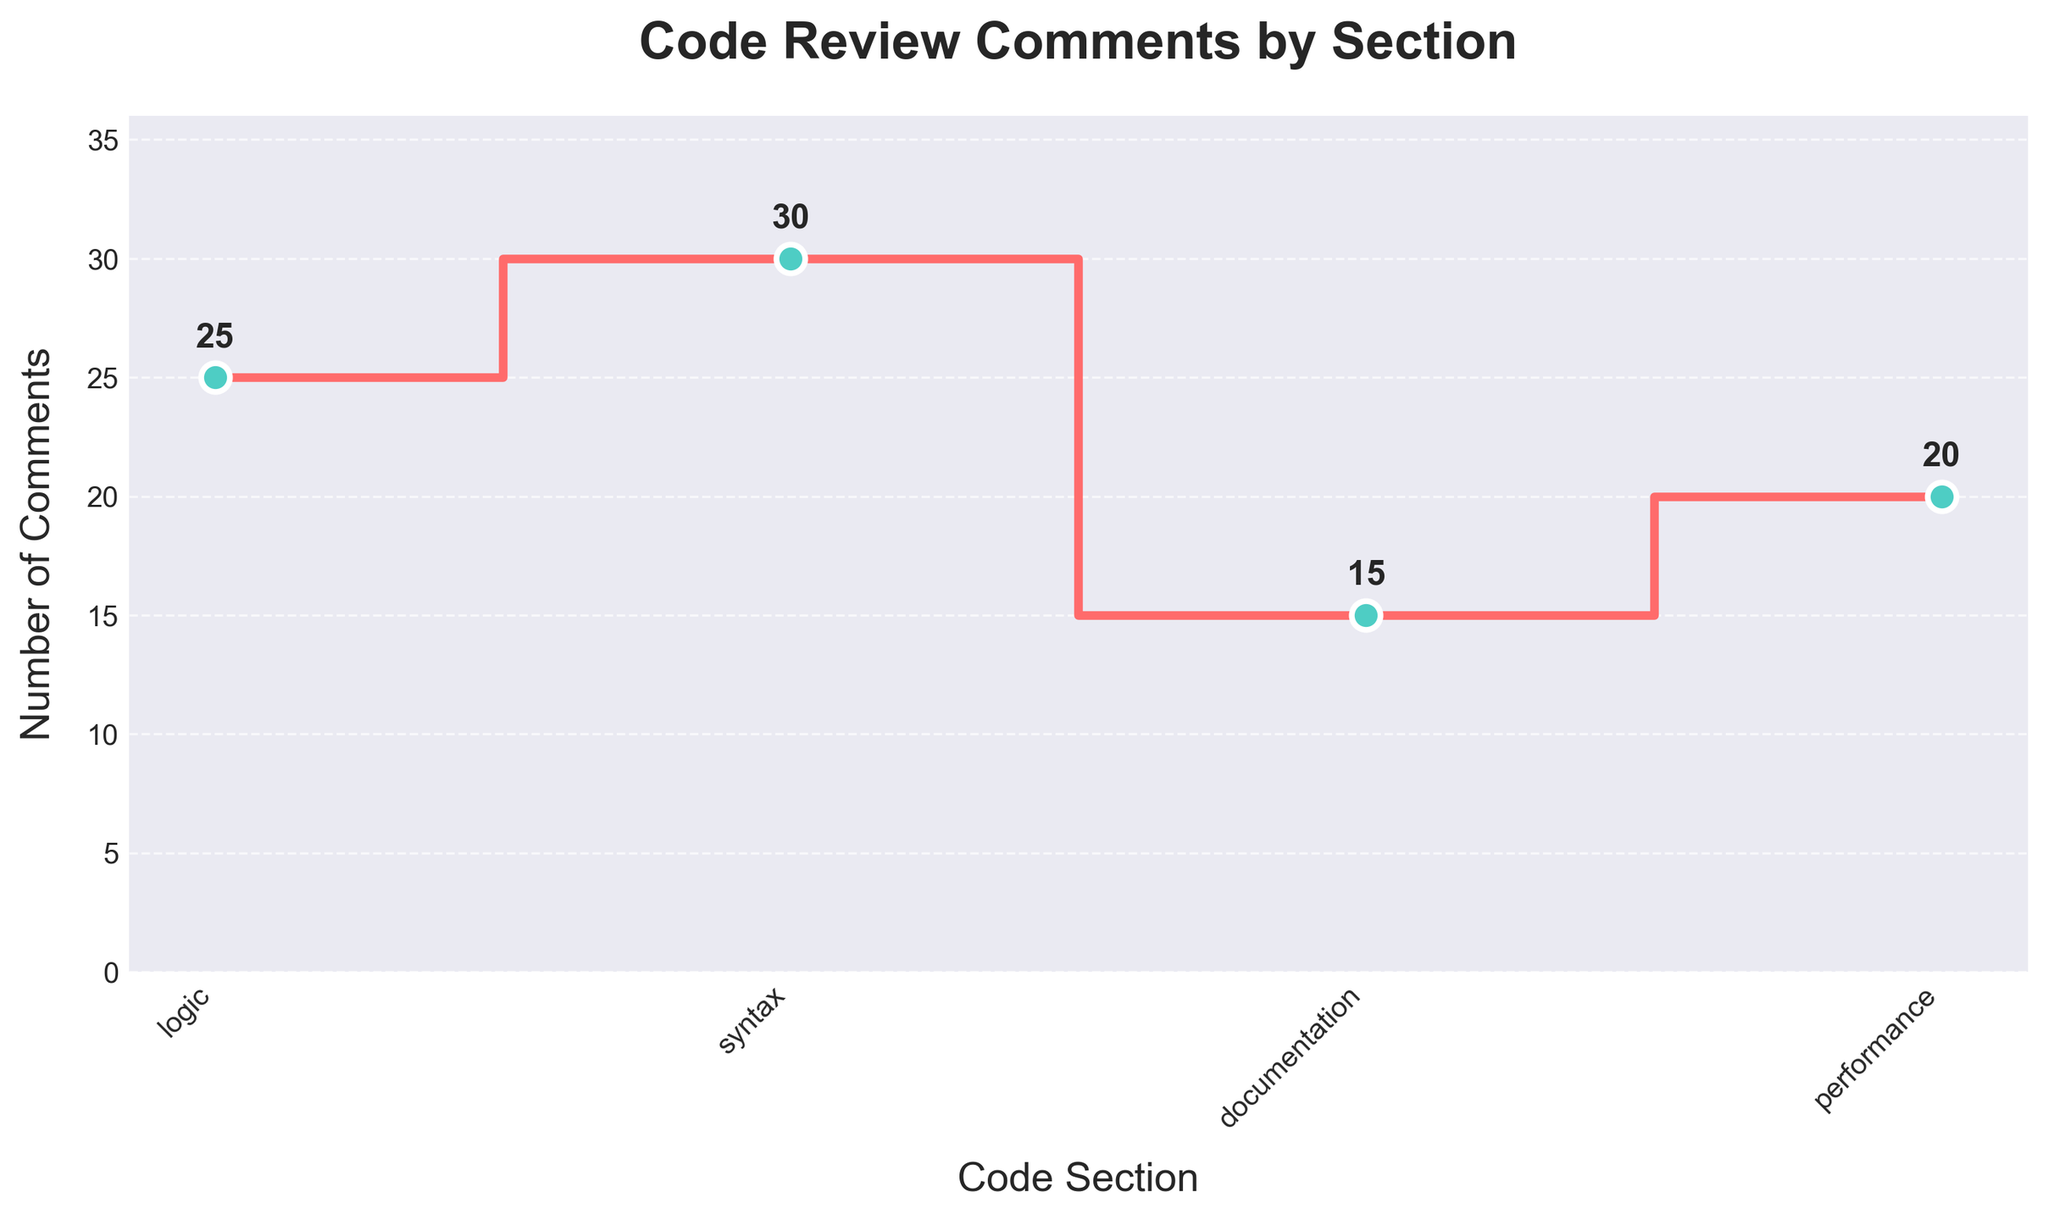How many sections are presented in the plot? The plot shows four distinct sections: logic, syntax, documentation, and performance. You can count the labels on the x-axis to determine the number of sections.
Answer: Four What is the highest number of comments in any section? To identify this, look for the highest point on the plot, which corresponds to the syntax section with thirty comments.
Answer: Thirty Which section has the fewest comments? Evaluate the plot to find the section with the lowest step, which is the documentation section with fifteen comments.
Answer: Documentation What's the sum of the code review comments for logic and performance sections combined? Add the comments from both the logic section (twenty-five) and the performance section (twenty) to get the total. 25 + 20 = 45
Answer: Forty-five What is the difference in code review comments between the syntax and documentation sections? Subtract the number of comments in the documentation section (fifteen) from the number of comments in the syntax section (thirty). 30 - 15 = 15
Answer: Fifteen Which section has more comments, performance or logic? Compare the values of the comments in the performance section (twenty) and the logic section (twenty-five). The logic section has more comments.
Answer: Logic How many comments are there on average per section? Calculate the average number of comments by summing all comments and dividing by the number of sections: (25 + 30 + 15 + 20) / 4 = 90 / 4 = 22.5
Answer: 22.5 How many steps are there in the plot? A step plot should show one step between each pair of adjacent sections. With four sections (logic, syntax, documentation, and performance), there are three steps: logic to syntax, syntax to documentation, and documentation to performance.
Answer: Three What is the color of the line connecting the data points? The color of the line connecting the data points is a distinctive shade of red (denoted as '#FF6B6B' in the code).
Answer: Red Is there a noticeable trend in the number of comments among the sections? By examining the plot, it appears that the number of comments increases from logic to syntax, then decreases towards documentation, and slightly increases again towards performance.
Answer: Yes 